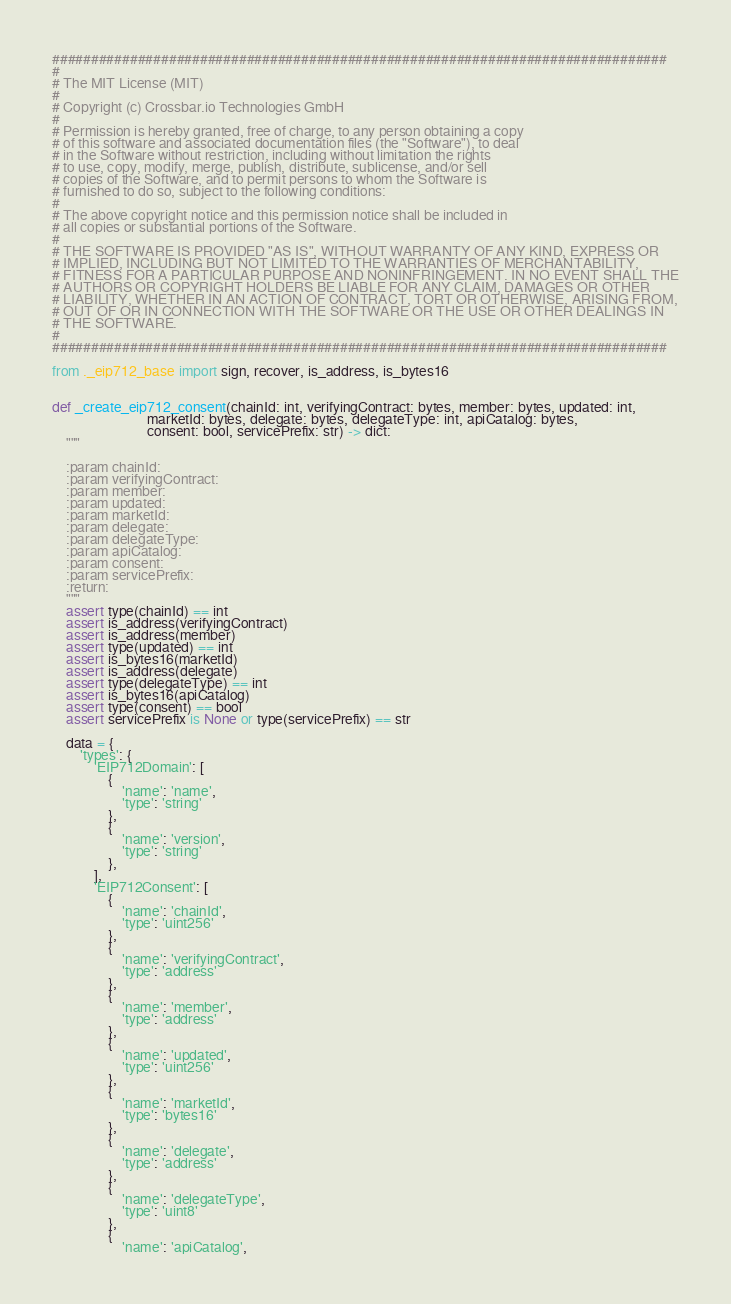Convert code to text. <code><loc_0><loc_0><loc_500><loc_500><_Python_>###############################################################################
#
# The MIT License (MIT)
#
# Copyright (c) Crossbar.io Technologies GmbH
#
# Permission is hereby granted, free of charge, to any person obtaining a copy
# of this software and associated documentation files (the "Software"), to deal
# in the Software without restriction, including without limitation the rights
# to use, copy, modify, merge, publish, distribute, sublicense, and/or sell
# copies of the Software, and to permit persons to whom the Software is
# furnished to do so, subject to the following conditions:
#
# The above copyright notice and this permission notice shall be included in
# all copies or substantial portions of the Software.
#
# THE SOFTWARE IS PROVIDED "AS IS", WITHOUT WARRANTY OF ANY KIND, EXPRESS OR
# IMPLIED, INCLUDING BUT NOT LIMITED TO THE WARRANTIES OF MERCHANTABILITY,
# FITNESS FOR A PARTICULAR PURPOSE AND NONINFRINGEMENT. IN NO EVENT SHALL THE
# AUTHORS OR COPYRIGHT HOLDERS BE LIABLE FOR ANY CLAIM, DAMAGES OR OTHER
# LIABILITY, WHETHER IN AN ACTION OF CONTRACT, TORT OR OTHERWISE, ARISING FROM,
# OUT OF OR IN CONNECTION WITH THE SOFTWARE OR THE USE OR OTHER DEALINGS IN
# THE SOFTWARE.
#
###############################################################################

from ._eip712_base import sign, recover, is_address, is_bytes16


def _create_eip712_consent(chainId: int, verifyingContract: bytes, member: bytes, updated: int,
                           marketId: bytes, delegate: bytes, delegateType: int, apiCatalog: bytes,
                           consent: bool, servicePrefix: str) -> dict:
    """

    :param chainId:
    :param verifyingContract:
    :param member:
    :param updated:
    :param marketId:
    :param delegate:
    :param delegateType:
    :param apiCatalog:
    :param consent:
    :param servicePrefix:
    :return:
    """
    assert type(chainId) == int
    assert is_address(verifyingContract)
    assert is_address(member)
    assert type(updated) == int
    assert is_bytes16(marketId)
    assert is_address(delegate)
    assert type(delegateType) == int
    assert is_bytes16(apiCatalog)
    assert type(consent) == bool
    assert servicePrefix is None or type(servicePrefix) == str

    data = {
        'types': {
            'EIP712Domain': [
                {
                    'name': 'name',
                    'type': 'string'
                },
                {
                    'name': 'version',
                    'type': 'string'
                },
            ],
            'EIP712Consent': [
                {
                    'name': 'chainId',
                    'type': 'uint256'
                },
                {
                    'name': 'verifyingContract',
                    'type': 'address'
                },
                {
                    'name': 'member',
                    'type': 'address'
                },
                {
                    'name': 'updated',
                    'type': 'uint256'
                },
                {
                    'name': 'marketId',
                    'type': 'bytes16'
                },
                {
                    'name': 'delegate',
                    'type': 'address'
                },
                {
                    'name': 'delegateType',
                    'type': 'uint8'
                },
                {
                    'name': 'apiCatalog',</code> 